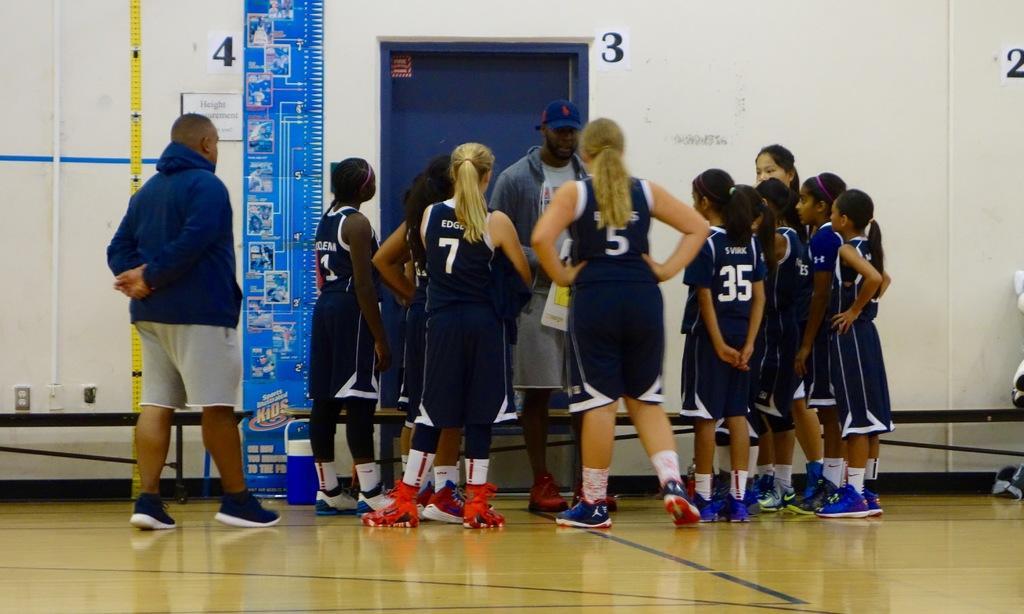Can you describe this image briefly? In this picture we can see a group of people wore shoes and standing on the ground and a man wore a cap and in the background we can see stickers on the wall, door, name board, box and some objects. 